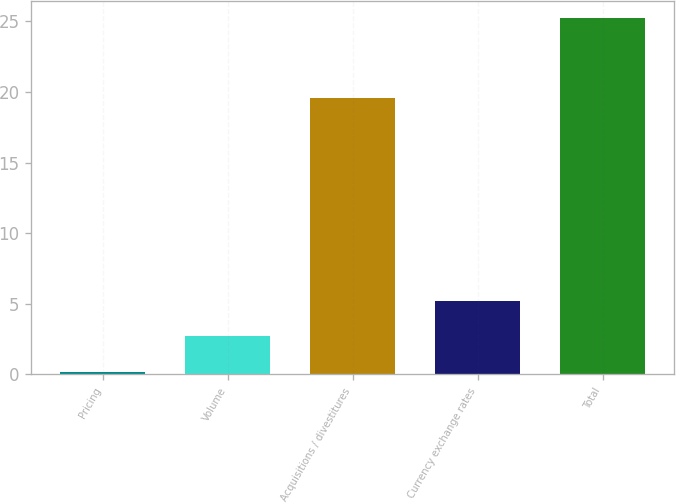Convert chart to OTSL. <chart><loc_0><loc_0><loc_500><loc_500><bar_chart><fcel>Pricing<fcel>Volume<fcel>Acquisitions / divestitures<fcel>Currency exchange rates<fcel>Total<nl><fcel>0.2<fcel>2.7<fcel>19.6<fcel>5.2<fcel>25.2<nl></chart> 